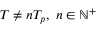Convert formula to latex. <formula><loc_0><loc_0><loc_500><loc_500>T \neq n T _ { p } , \ n \in \mathbb { N } ^ { + }</formula> 